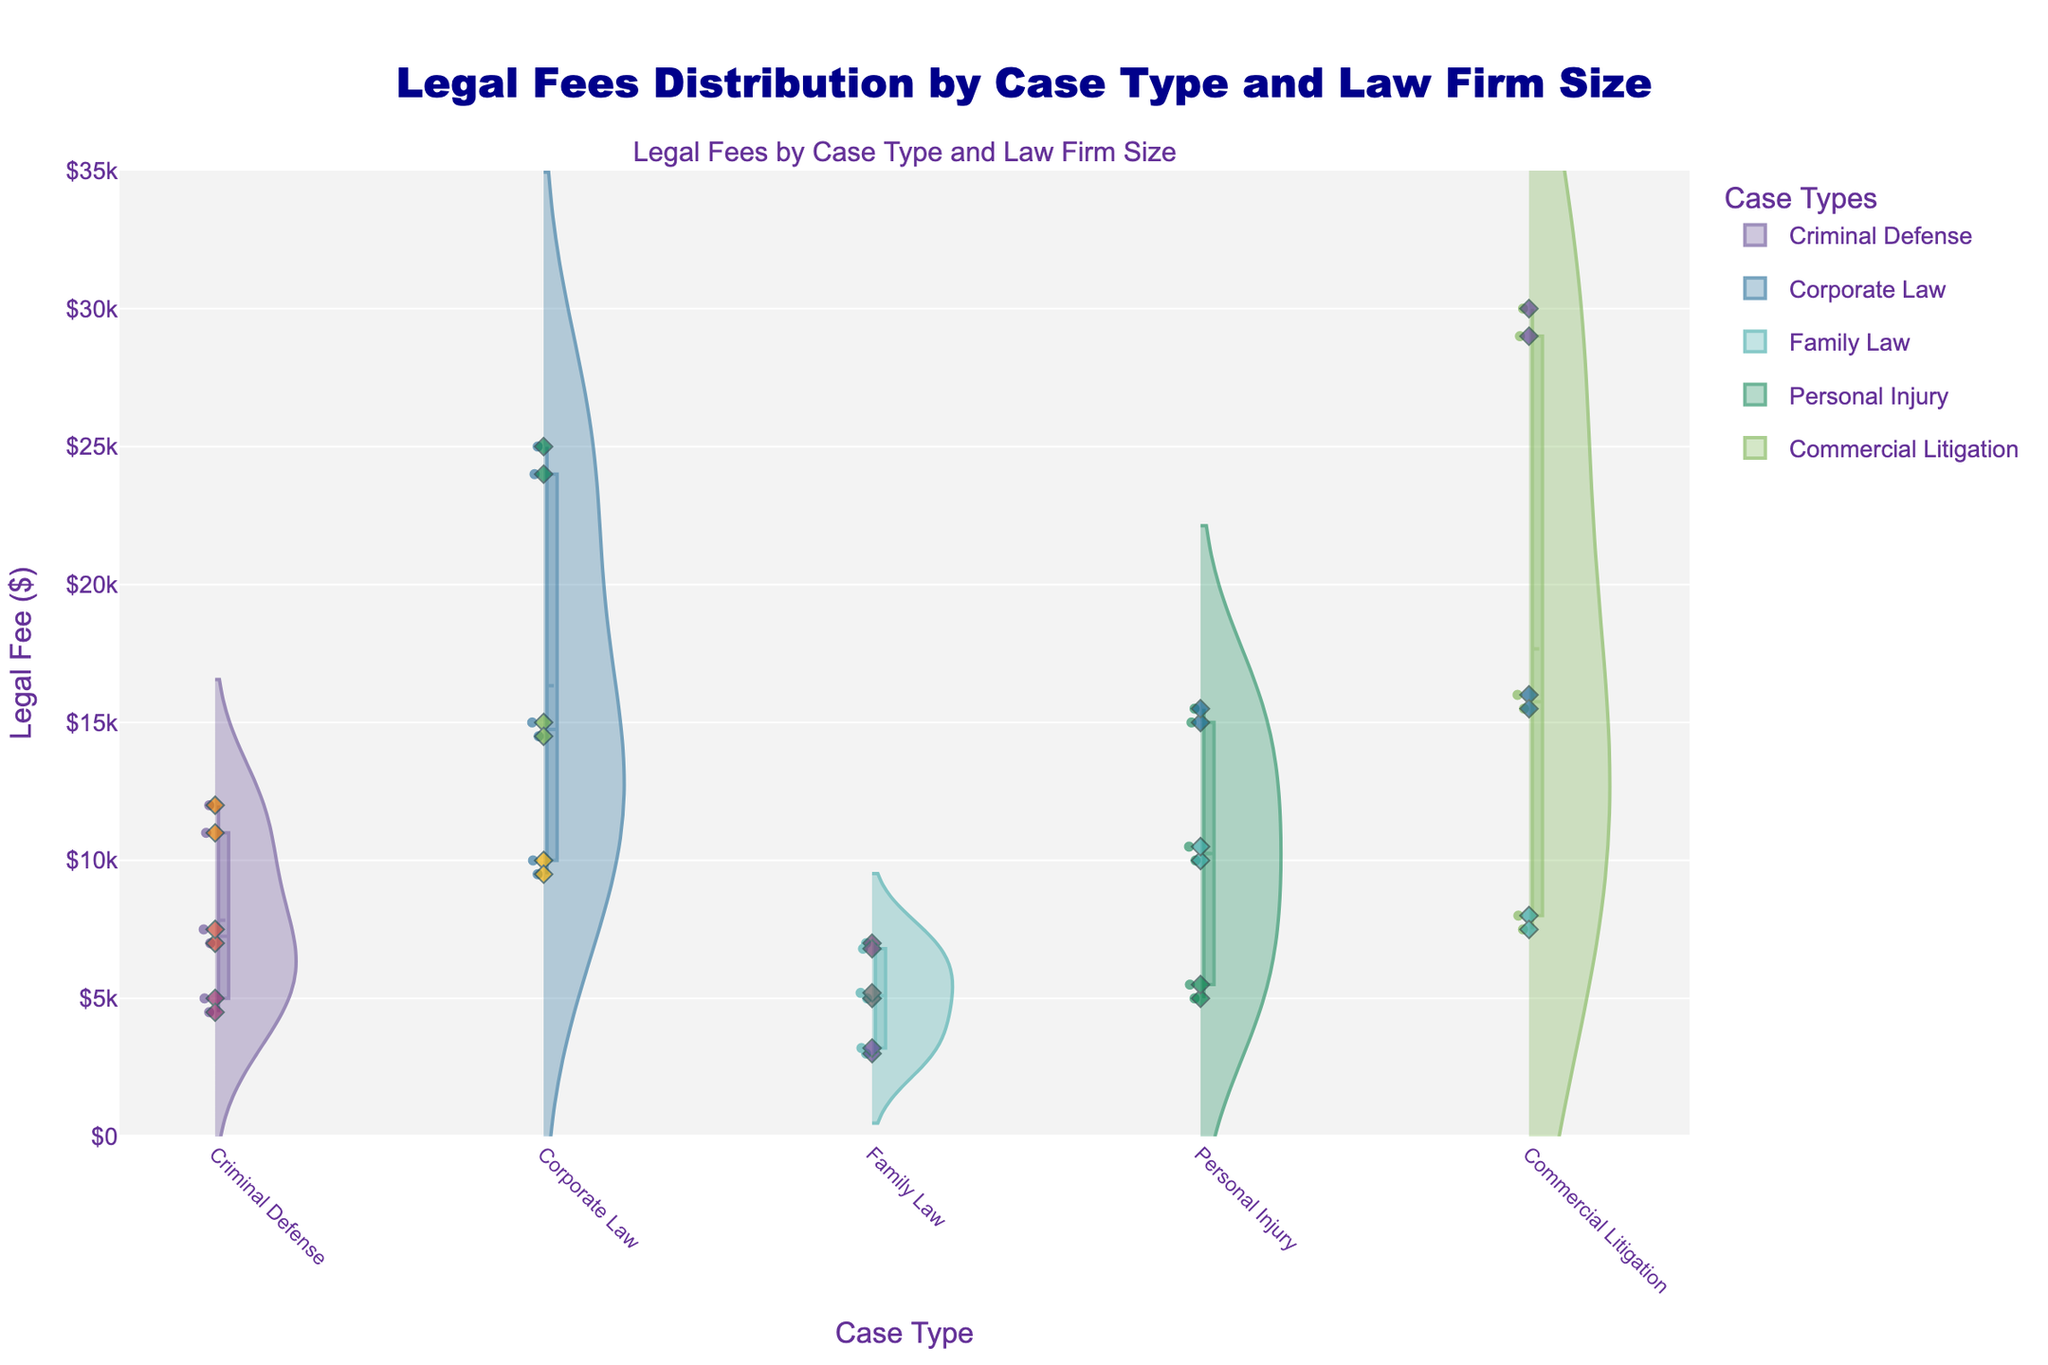How many different case types are represented in the plot? The x-axis of the violin chart lists all the unique case types. By counting them, we see Criminal Defense, Corporate Law, Family Law, Personal Injury, and Commercial Litigation.
Answer: 5 Which case type and law firm size combination has the highest legal fee? Observing the violin chart with jittered points, the highest spike in the vertical axis is in the range above $29000 for the Commercial Litigation case handled by Large firms.
Answer: Commercial Litigation - Large What is the average legal fee for Family Law cases across all firm sizes? For Family Law, the fees are represented as $3000, $3200, $5000, $5200, $7000, and $6800. The sum of these values is $30200, and there are 6 points. Thus, the average is calculated as $30200/6.
Answer: $5033.33 What is the median legal fee for Corporate Law cases handled by Small Law Firms? The data points for Corporate Law - Small Law Firms are $10000 and $9500. The median of two points is the average of them, (10000+9500)/2.
Answer: $9750 Which case type has the narrowest range of legal fees? Range can be observed by the spread of the violin plot. Family Law has a closely packed violin plot indicating a narrow range of $3000-$7000 compared to others.
Answer: Family Law 